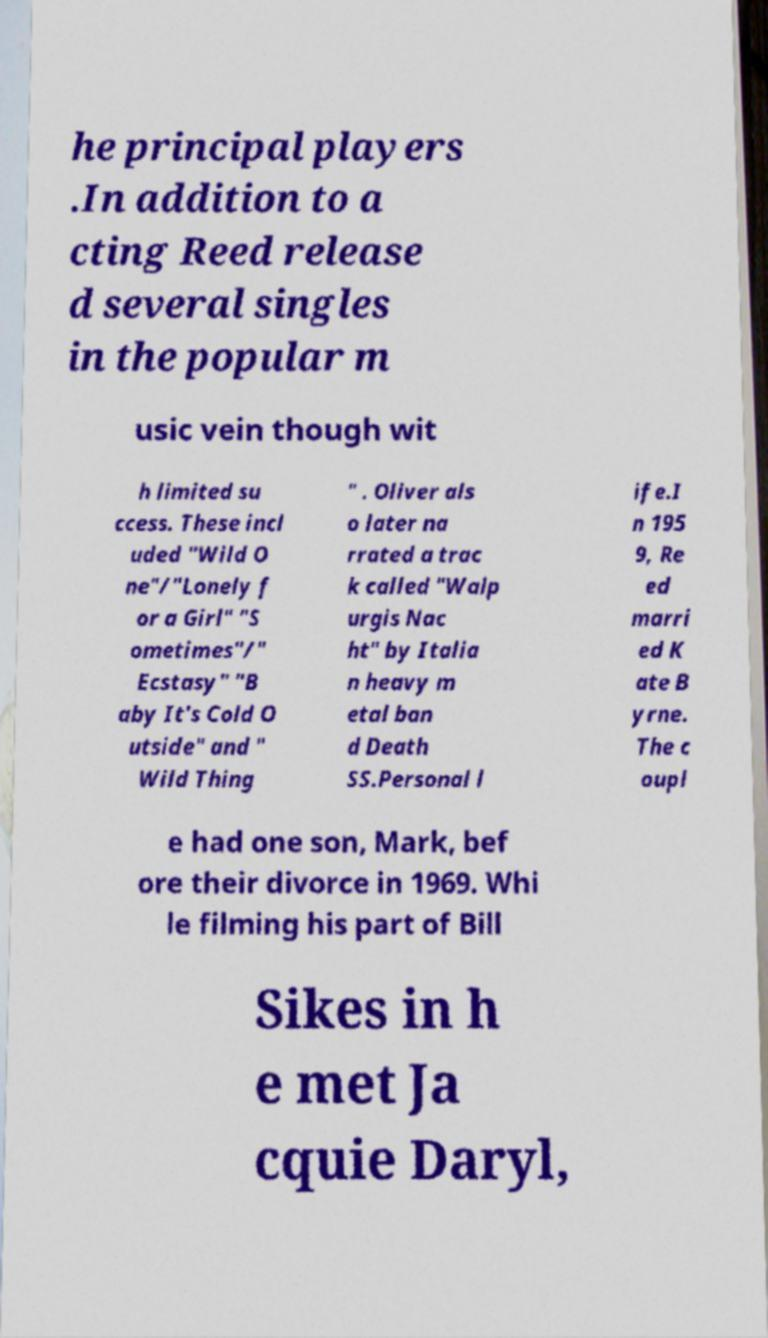Can you accurately transcribe the text from the provided image for me? he principal players .In addition to a cting Reed release d several singles in the popular m usic vein though wit h limited su ccess. These incl uded "Wild O ne"/"Lonely f or a Girl" "S ometimes"/" Ecstasy" "B aby It's Cold O utside" and " Wild Thing " . Oliver als o later na rrated a trac k called "Walp urgis Nac ht" by Italia n heavy m etal ban d Death SS.Personal l ife.I n 195 9, Re ed marri ed K ate B yrne. The c oupl e had one son, Mark, bef ore their divorce in 1969. Whi le filming his part of Bill Sikes in h e met Ja cquie Daryl, 